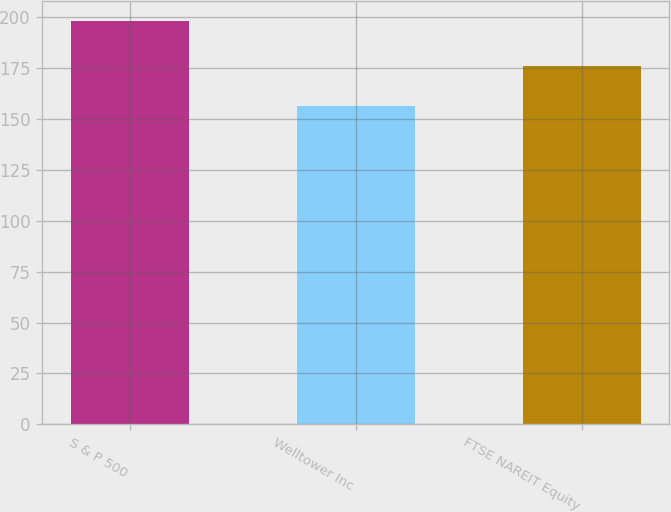Convert chart to OTSL. <chart><loc_0><loc_0><loc_500><loc_500><bar_chart><fcel>S & P 500<fcel>Welltower Inc<fcel>FTSE NAREIT Equity<nl><fcel>198.18<fcel>156.69<fcel>176.3<nl></chart> 